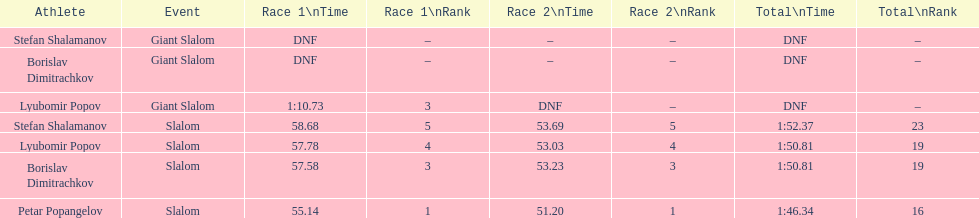Who was last in the slalom overall? Stefan Shalamanov. 